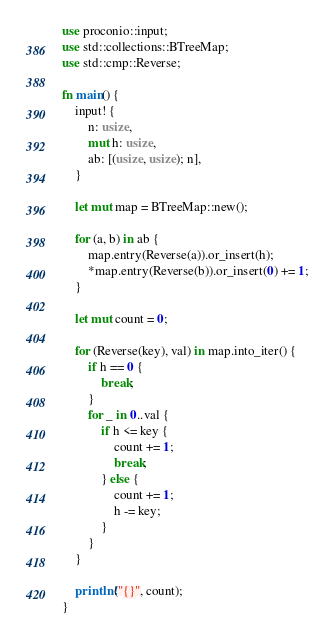Convert code to text. <code><loc_0><loc_0><loc_500><loc_500><_Rust_>use proconio::input;
use std::collections::BTreeMap;
use std::cmp::Reverse;

fn main() {
    input! {
        n: usize,
        mut h: usize,
        ab: [(usize, usize); n],
    }

    let mut map = BTreeMap::new();

    for (a, b) in ab {
        map.entry(Reverse(a)).or_insert(h);
        *map.entry(Reverse(b)).or_insert(0) += 1;
    }

    let mut count = 0;

    for (Reverse(key), val) in map.into_iter() {
        if h == 0 {
            break;
        }
        for _ in 0..val {
            if h <= key {
                count += 1;
                break;
            } else {
                count += 1;
                h -= key;
            }
        }
    }

    println!("{}", count);
}
</code> 